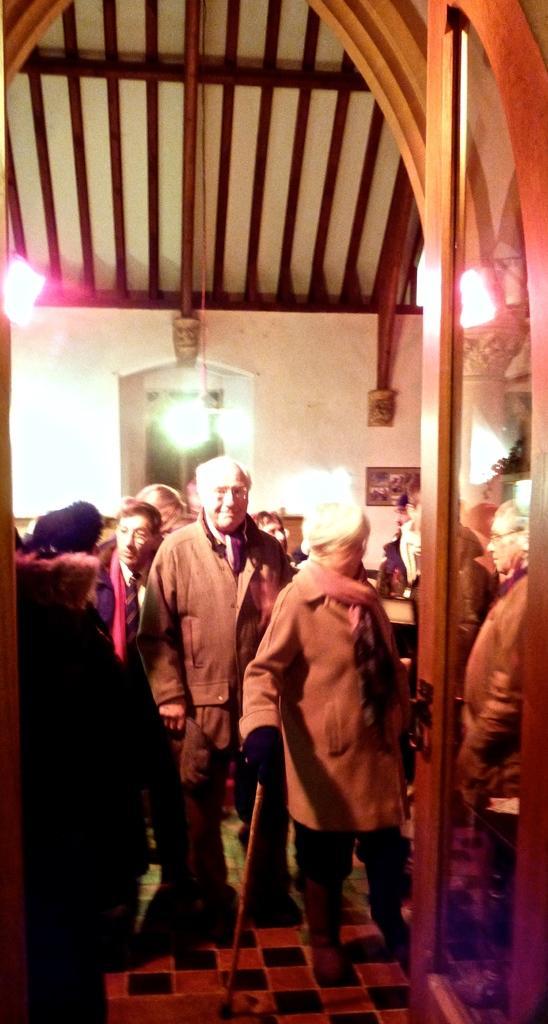Can you describe this image briefly? In this picture there is an old man who is wearing spectacles, jacket, trouser and shoe. He is standing near to the woman who is wearing jacket, gloves and shoe. She is holding a stick. On the right we can see glass door. On the top we can see wooden roof. Here we can see light near to the window. On the left we can see group of persons who are dancing. 